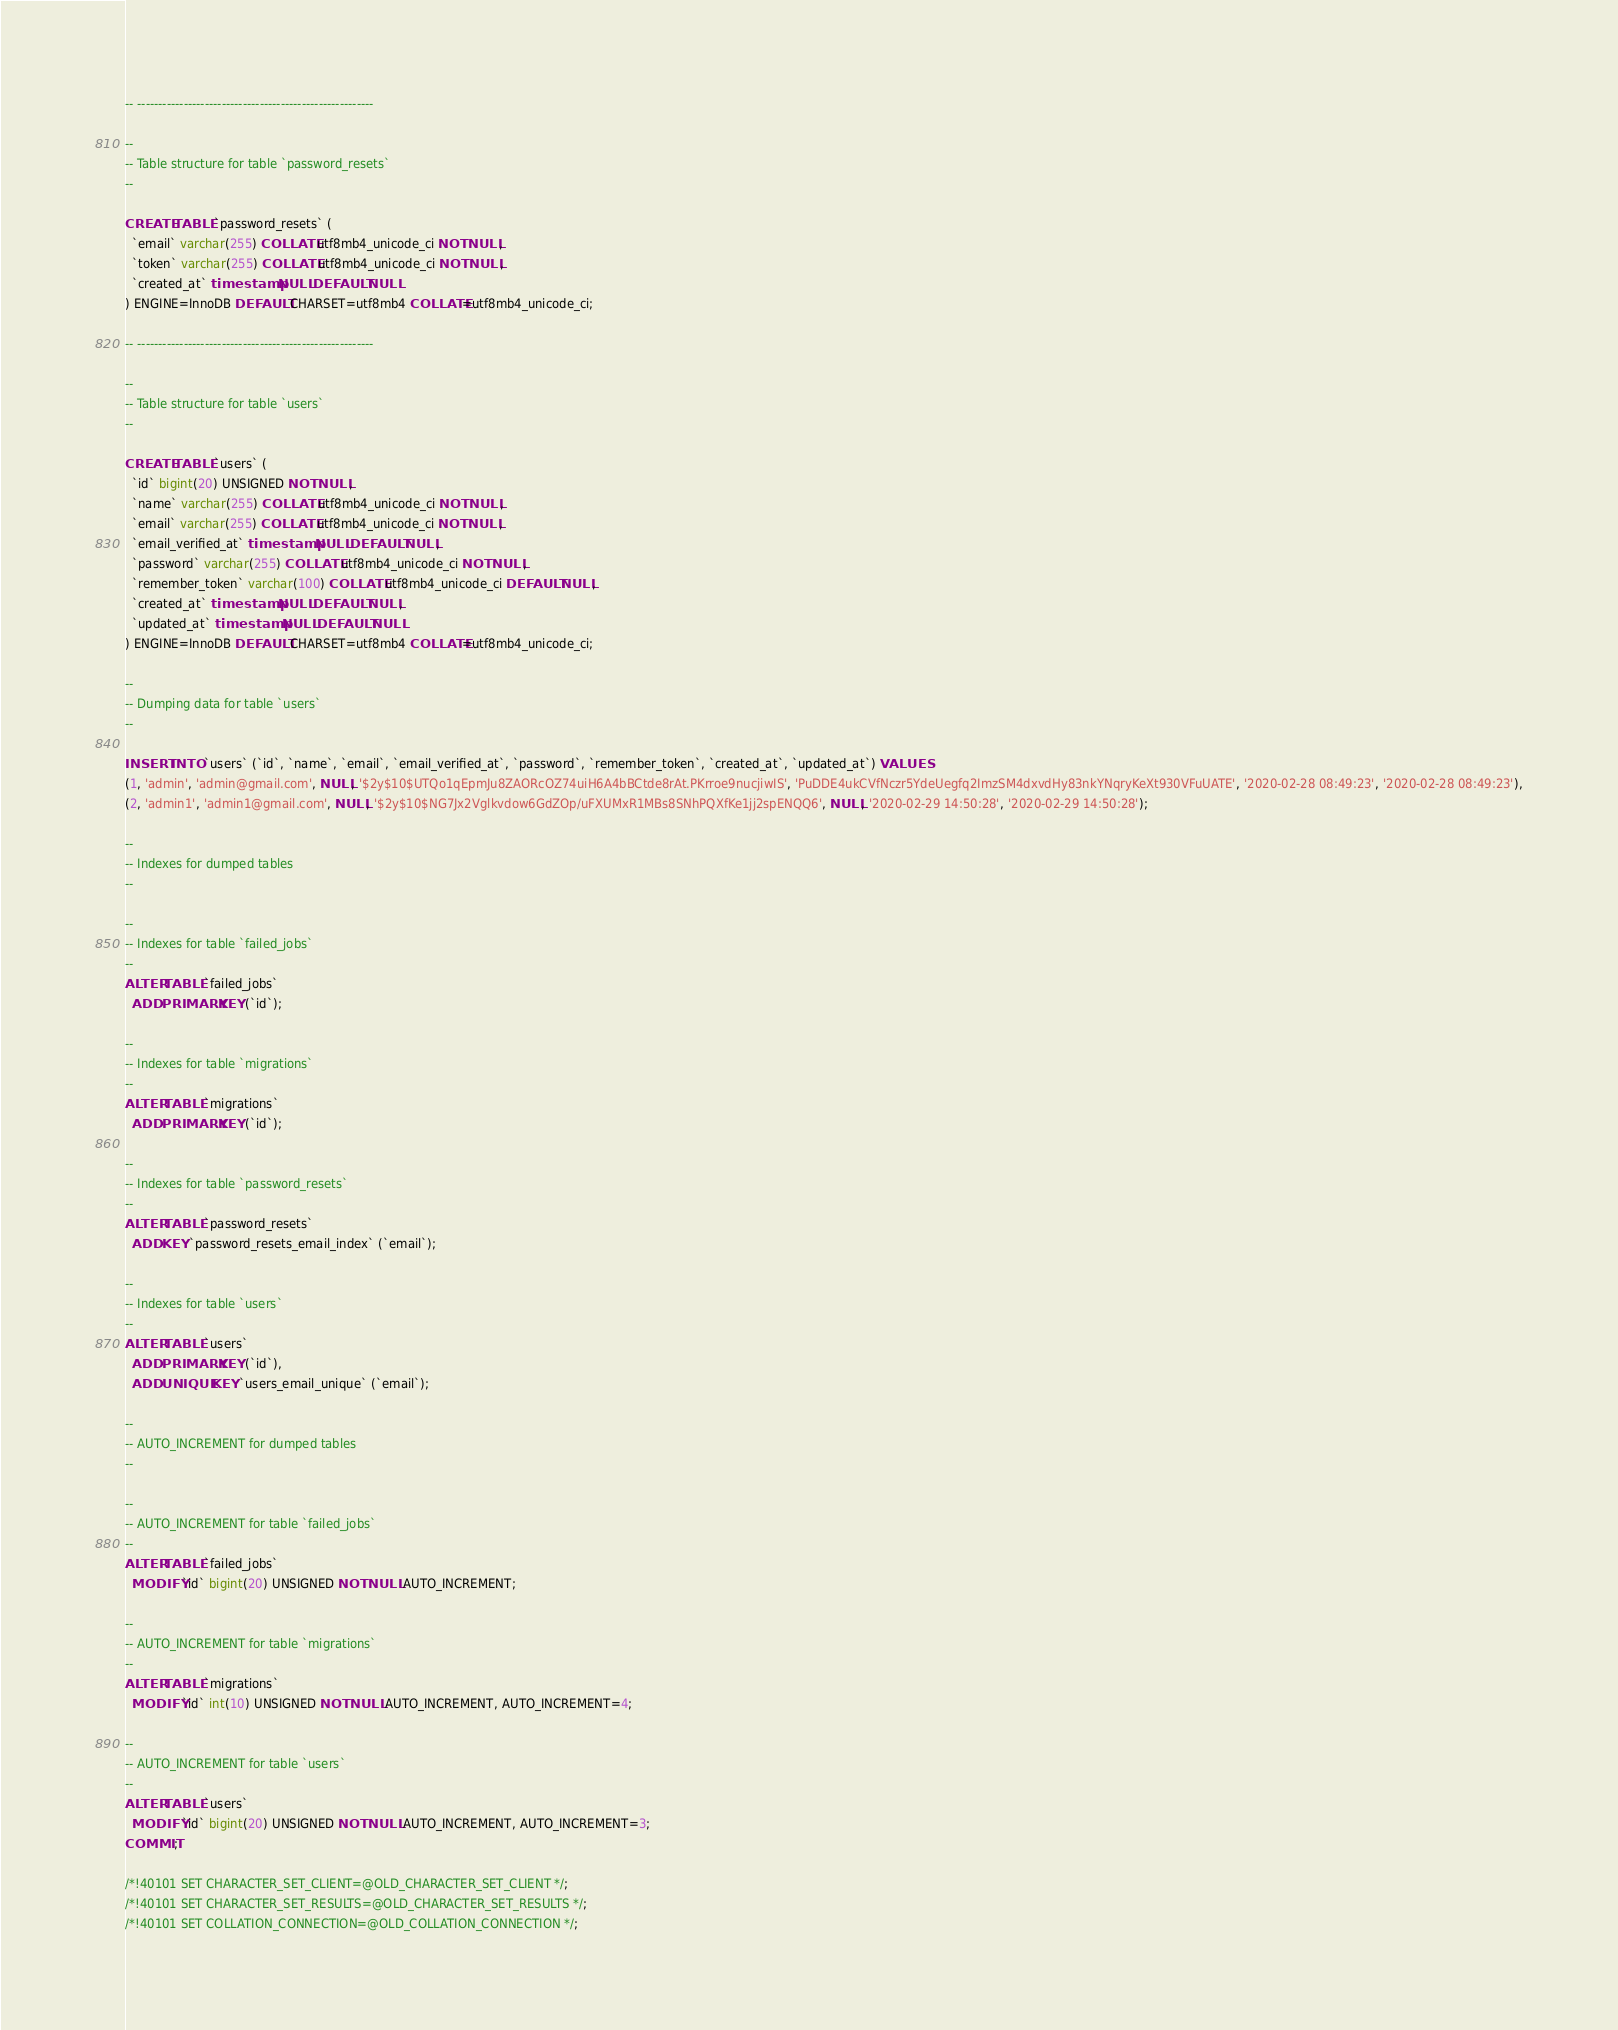<code> <loc_0><loc_0><loc_500><loc_500><_SQL_>-- --------------------------------------------------------

--
-- Table structure for table `password_resets`
--

CREATE TABLE `password_resets` (
  `email` varchar(255) COLLATE utf8mb4_unicode_ci NOT NULL,
  `token` varchar(255) COLLATE utf8mb4_unicode_ci NOT NULL,
  `created_at` timestamp NULL DEFAULT NULL
) ENGINE=InnoDB DEFAULT CHARSET=utf8mb4 COLLATE=utf8mb4_unicode_ci;

-- --------------------------------------------------------

--
-- Table structure for table `users`
--

CREATE TABLE `users` (
  `id` bigint(20) UNSIGNED NOT NULL,
  `name` varchar(255) COLLATE utf8mb4_unicode_ci NOT NULL,
  `email` varchar(255) COLLATE utf8mb4_unicode_ci NOT NULL,
  `email_verified_at` timestamp NULL DEFAULT NULL,
  `password` varchar(255) COLLATE utf8mb4_unicode_ci NOT NULL,
  `remember_token` varchar(100) COLLATE utf8mb4_unicode_ci DEFAULT NULL,
  `created_at` timestamp NULL DEFAULT NULL,
  `updated_at` timestamp NULL DEFAULT NULL
) ENGINE=InnoDB DEFAULT CHARSET=utf8mb4 COLLATE=utf8mb4_unicode_ci;

--
-- Dumping data for table `users`
--

INSERT INTO `users` (`id`, `name`, `email`, `email_verified_at`, `password`, `remember_token`, `created_at`, `updated_at`) VALUES
(1, 'admin', 'admin@gmail.com', NULL, '$2y$10$UTQo1qEpmJu8ZAORcOZ74uiH6A4bBCtde8rAt.PKrroe9nucjiwIS', 'PuDDE4ukCVfNczr5YdeUegfq2ImzSM4dxvdHy83nkYNqryKeXt930VFuUATE', '2020-02-28 08:49:23', '2020-02-28 08:49:23'),
(2, 'admin1', 'admin1@gmail.com', NULL, '$2y$10$NG7Jx2Vglkvdow6GdZOp/uFXUMxR1MBs8SNhPQXfKe1jj2spENQQ6', NULL, '2020-02-29 14:50:28', '2020-02-29 14:50:28');

--
-- Indexes for dumped tables
--

--
-- Indexes for table `failed_jobs`
--
ALTER TABLE `failed_jobs`
  ADD PRIMARY KEY (`id`);

--
-- Indexes for table `migrations`
--
ALTER TABLE `migrations`
  ADD PRIMARY KEY (`id`);

--
-- Indexes for table `password_resets`
--
ALTER TABLE `password_resets`
  ADD KEY `password_resets_email_index` (`email`);

--
-- Indexes for table `users`
--
ALTER TABLE `users`
  ADD PRIMARY KEY (`id`),
  ADD UNIQUE KEY `users_email_unique` (`email`);

--
-- AUTO_INCREMENT for dumped tables
--

--
-- AUTO_INCREMENT for table `failed_jobs`
--
ALTER TABLE `failed_jobs`
  MODIFY `id` bigint(20) UNSIGNED NOT NULL AUTO_INCREMENT;

--
-- AUTO_INCREMENT for table `migrations`
--
ALTER TABLE `migrations`
  MODIFY `id` int(10) UNSIGNED NOT NULL AUTO_INCREMENT, AUTO_INCREMENT=4;

--
-- AUTO_INCREMENT for table `users`
--
ALTER TABLE `users`
  MODIFY `id` bigint(20) UNSIGNED NOT NULL AUTO_INCREMENT, AUTO_INCREMENT=3;
COMMIT;

/*!40101 SET CHARACTER_SET_CLIENT=@OLD_CHARACTER_SET_CLIENT */;
/*!40101 SET CHARACTER_SET_RESULTS=@OLD_CHARACTER_SET_RESULTS */;
/*!40101 SET COLLATION_CONNECTION=@OLD_COLLATION_CONNECTION */;
</code> 